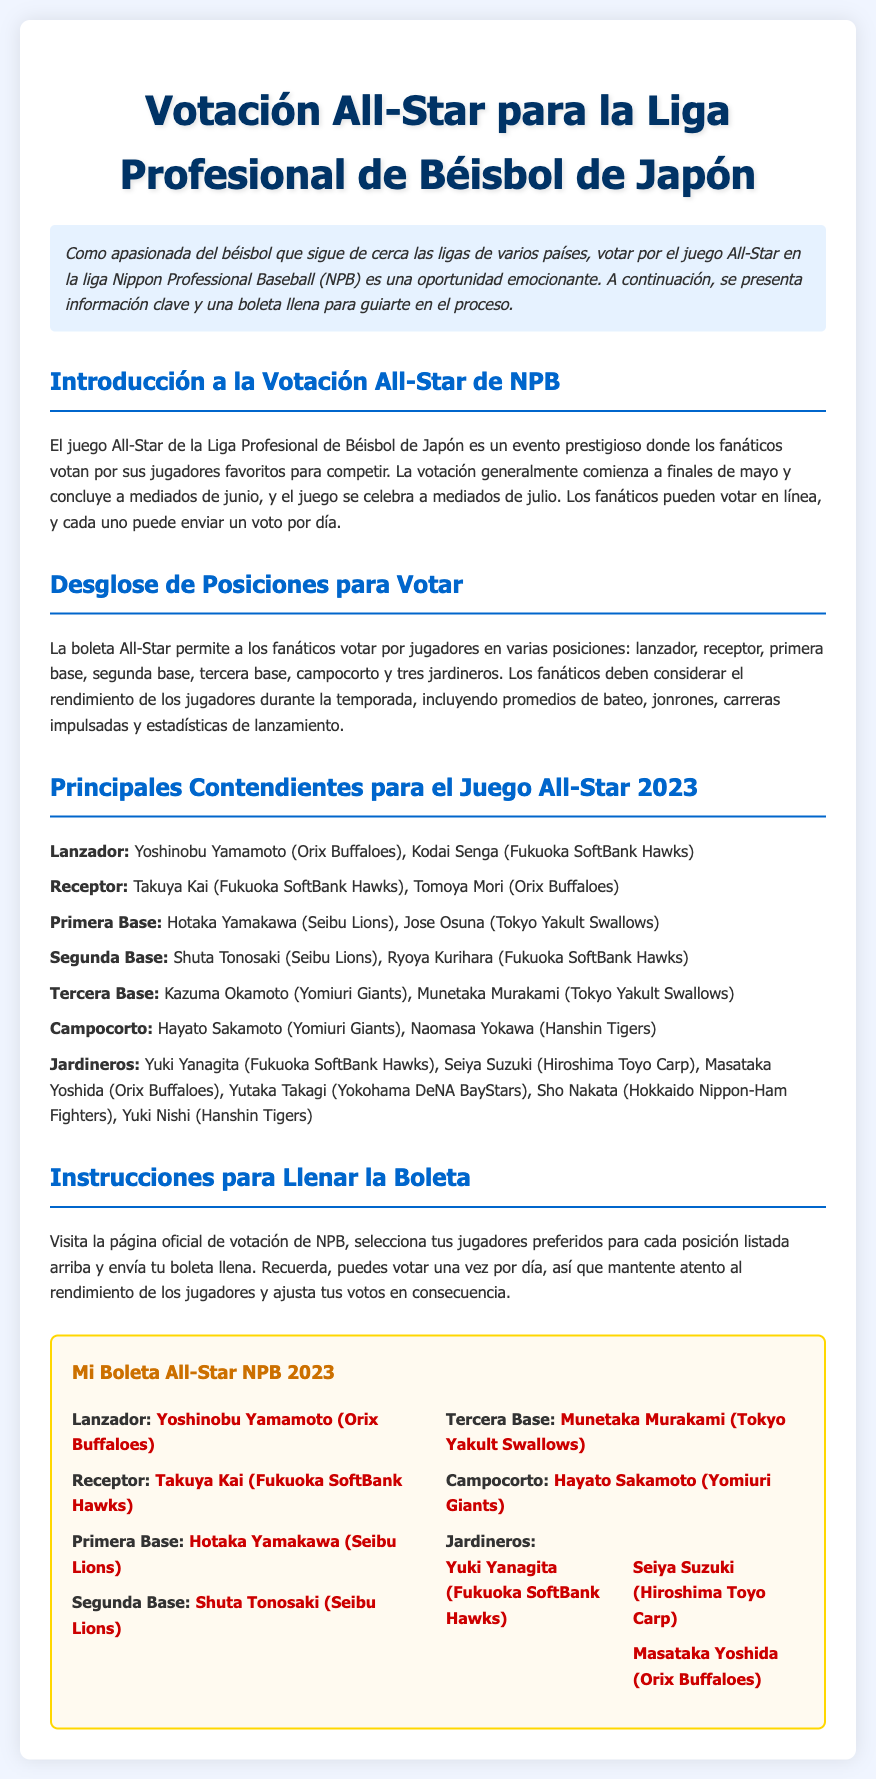¿Cuándo comienza la votación All-Star de NPB? La votación generalmente comienza a finales de mayo.
Answer: finales de mayo ¿Quién es el receptor destacado en la boleta? El receptor destacado en la boleta es Takuya Kai.
Answer: Takuya Kai ¿Cuántos jardineros se pueden seleccionar en la boleta? Los fanáticos pueden seleccionar tres jardineros en la boleta.
Answer: tres ¿Quiénes son los principales contendientes para la posición de lanzador? Los principales contendientes para la posición de lanzador son Yoshinobu Yamamoto y Kodai Senga.
Answer: Yoshinobu Yamamoto, Kodai Senga ¿Cuál es el equipo de Hotaka Yamakawa? Hotaka Yamakawa juega para los Seibu Lions.
Answer: Seibu Lions ¿Qué jugador de tercera base está en la boleta? El jugador de tercera base en la boleta es Munetaka Murakami.
Answer: Munetaka Murakami ¿Cuántas posiciones se pueden votar en total? Se pueden votar siete posiciones en total.
Answer: siete ¿Dónde se pueden enviar las boletas de votación? Las boletas se pueden enviar a través de la página oficial de votación de NPB.
Answer: página oficial de votación de NPB 